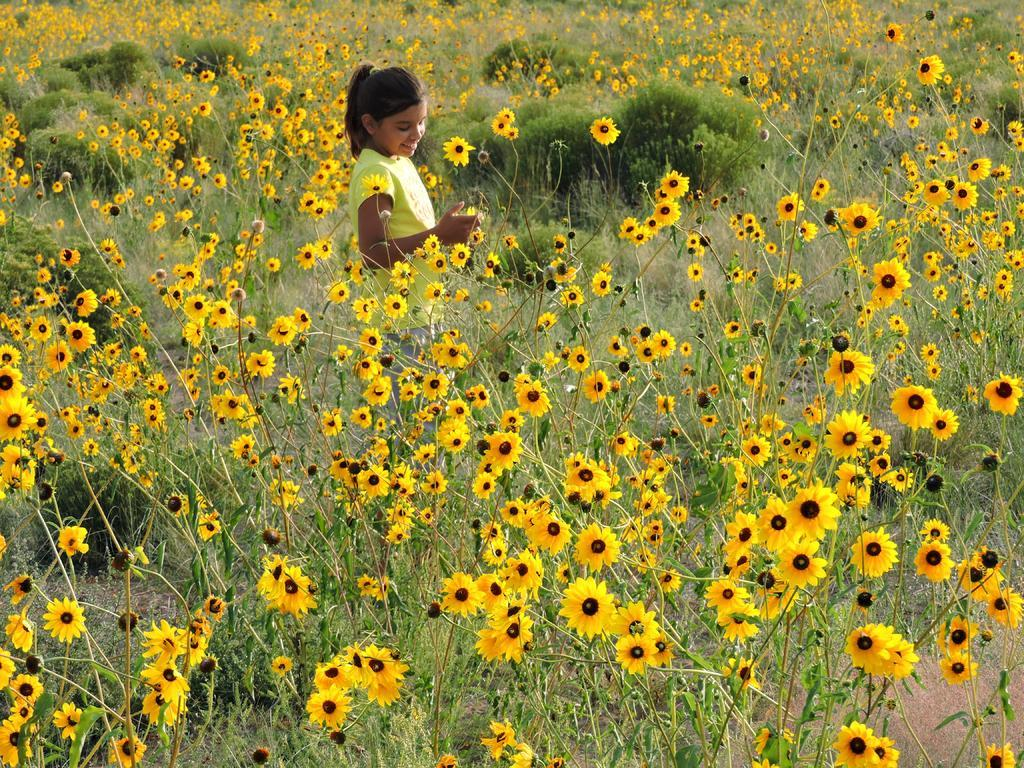What type of living organisms can be seen in the image? There are flowers and plants visible in the image. Can you describe the person in the image? There is a person standing in the image, and they are smiling. What type of cloth is being used for the voyage in the image? There is no voyage or cloth present in the image. What hour of the day is depicted in the image? The image does not provide information about the time of day. 